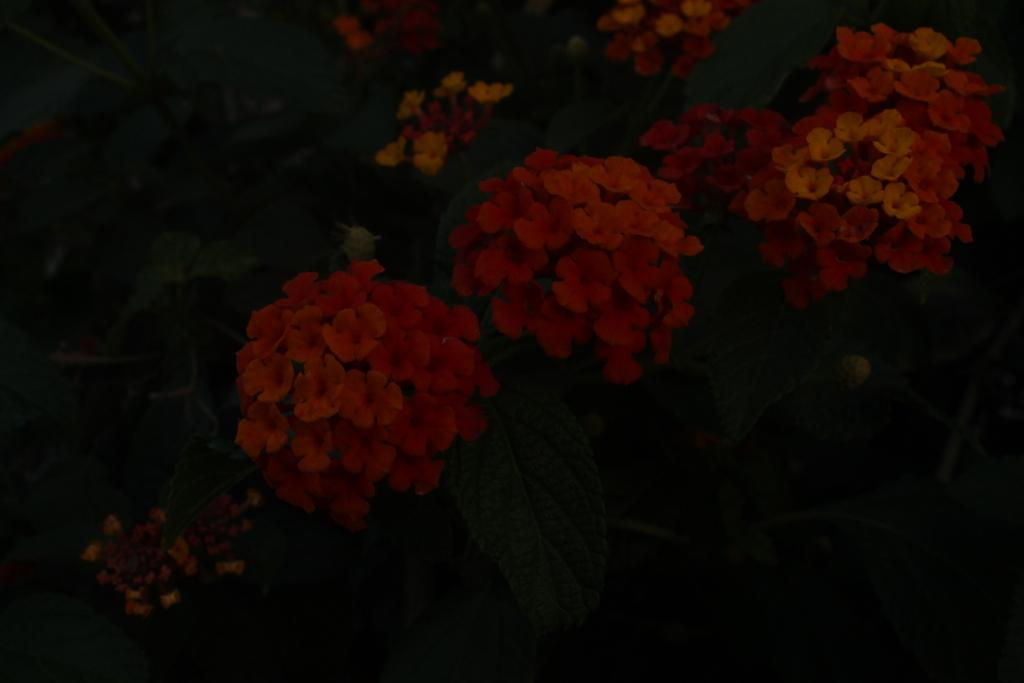What type of plants can be seen in the image? There are many flower plants in the image. Where are the flower plants located? The flower plants are on the land. How many times does the flower plant sneeze in the image? Flower plants do not sneeze, so this question cannot be answered. 